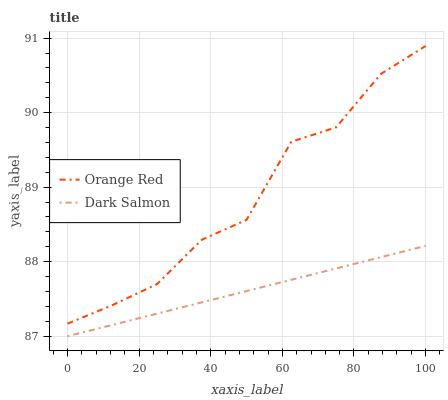Does Dark Salmon have the minimum area under the curve?
Answer yes or no. Yes. Does Orange Red have the maximum area under the curve?
Answer yes or no. Yes. Does Dark Salmon have the maximum area under the curve?
Answer yes or no. No. Is Dark Salmon the smoothest?
Answer yes or no. Yes. Is Orange Red the roughest?
Answer yes or no. Yes. Is Dark Salmon the roughest?
Answer yes or no. No. Does Orange Red have the highest value?
Answer yes or no. Yes. Does Dark Salmon have the highest value?
Answer yes or no. No. Is Dark Salmon less than Orange Red?
Answer yes or no. Yes. Is Orange Red greater than Dark Salmon?
Answer yes or no. Yes. Does Dark Salmon intersect Orange Red?
Answer yes or no. No. 